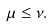Convert formula to latex. <formula><loc_0><loc_0><loc_500><loc_500>\mu \leq \nu .</formula> 